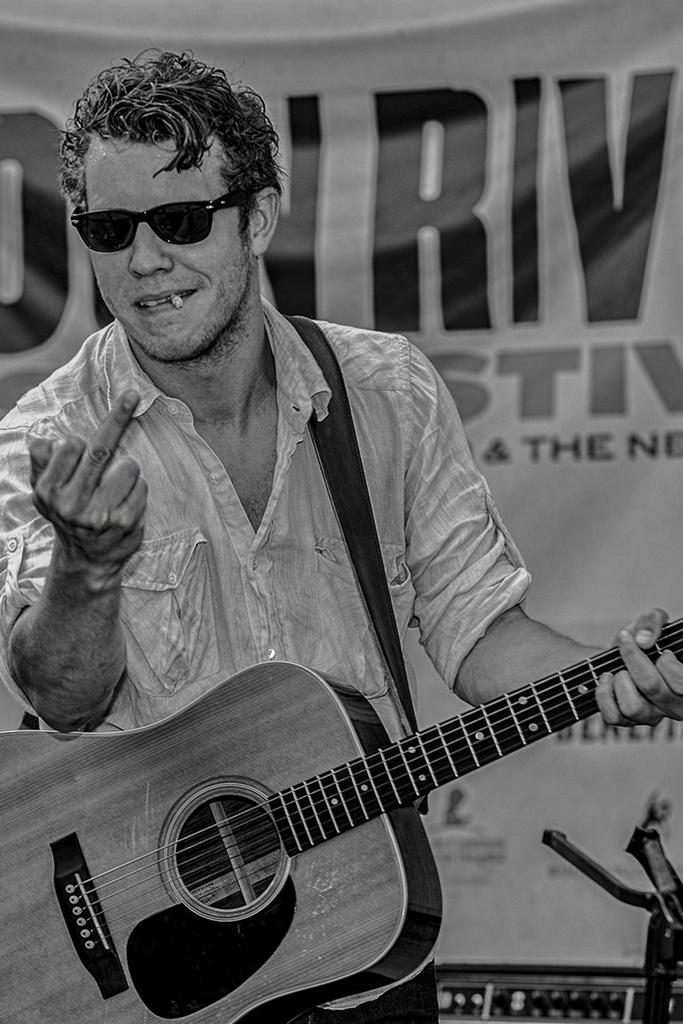What is the man in the image holding? The man is holding a guitar. What else can be seen in the man's mouth? The man has a cigarette in his mouth. What is visible in the background of the image? There is a poster in the background of the image. Can you tell me how many donkeys are visible in the image? There are no donkeys present in the image. What type of whip is the man using to play the guitar in the image? There is no whip present in the image, and the man is not using any whip to play the guitar. 